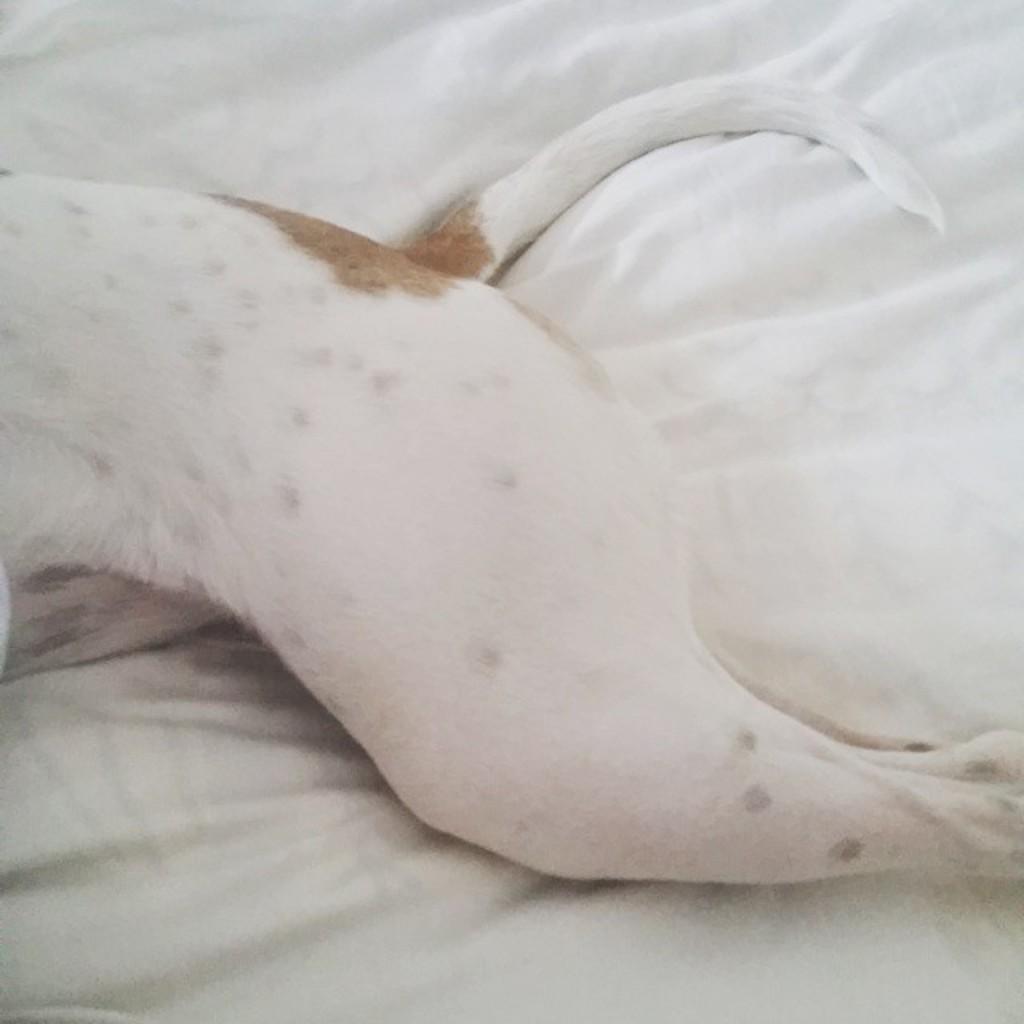Can you describe this image briefly? In this picture we can see an animal on the white cloth. 